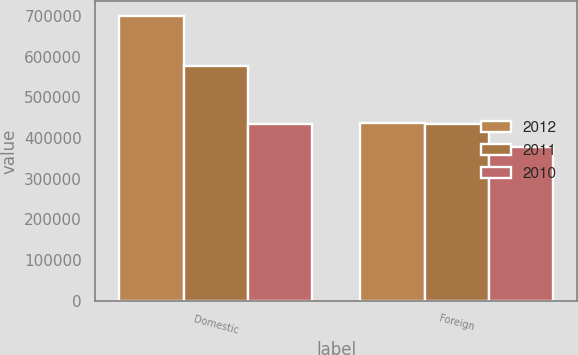Convert chart. <chart><loc_0><loc_0><loc_500><loc_500><stacked_bar_chart><ecel><fcel>Domestic<fcel>Foreign<nl><fcel>2012<fcel>700745<fcel>436826<nl><fcel>2011<fcel>577142<fcel>433120<nl><fcel>2010<fcel>434349<fcel>378773<nl></chart> 